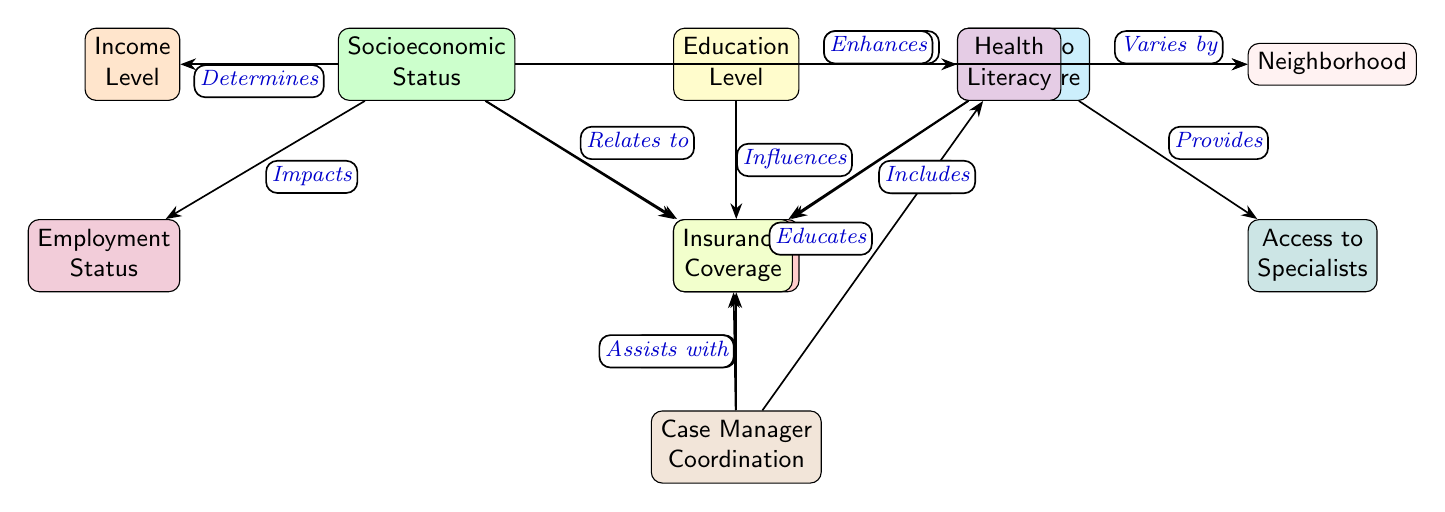What are the three main factors affecting patient outcomes? The diagram indicates three main factors that influence patient outcomes: Socioeconomic Status, Education Level, and Access to Healthcare.
Answer: Socioeconomic Status, Education Level, Access to Healthcare How many nodes are there in the diagram? By counting all the unique elements depicted, including Patient Outcomes and the factors impacting it, there are a total of 11 nodes in the diagram.
Answer: 11 What type of influence does Education Level have on Patient Outcomes? The diagram specifies that Education Level "Influences" Patient Outcomes, highlighting its role in determining recovery rates.
Answer: Influences What factor is shown to relate to Insurance Coverage? Socioeconomic Status is indicated in the diagram as a determining factor that "Relates to" Insurance Coverage, suggesting a connection between these two nodes.
Answer: Socioeconomic Status Which node is directly affected by Case Manager Coordination? The diagram illustrates that Case Manager Coordination "Improves" Patient Outcomes, linking the role of case management to the success of recovery rates.
Answer: Patient Outcomes What does Access to Healthcare determine? Access to Healthcare is illustrated in the diagram as determining Insurance Coverage, indicating that it plays a critical role in the type of insurance a patient can obtain.
Answer: Insurance Coverage List all the nodes that influence Patient Outcomes. The diagram shows that Socioeconomic Status, Education Level, and Access to Healthcare all influence Patient Outcomes. Therefore, the nodes impacting this outcome are collectively these three.
Answer: Socioeconomic Status, Education Level, Access to Healthcare How does Access to Specialists relate to Patient Outcomes? According to the diagram, Access to Specialists is part of the broader node Access to Healthcare and is labeled as a component that "Provides" support, ultimately affecting Patient Outcomes.
Answer: Provides Which node is associated with Health Literacy? The diagram states that Education Level "Enhances" Health Literacy, connecting the level of education with the understanding of health-related information.
Answer: Education Level 